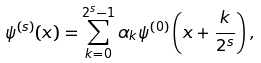<formula> <loc_0><loc_0><loc_500><loc_500>\psi ^ { ( s ) } ( x ) = \sum _ { k = 0 } ^ { 2 ^ { s } - 1 } \alpha _ { k } \psi ^ { ( 0 ) } \left ( x + \frac { k } { 2 ^ { s } } \right ) ,</formula> 